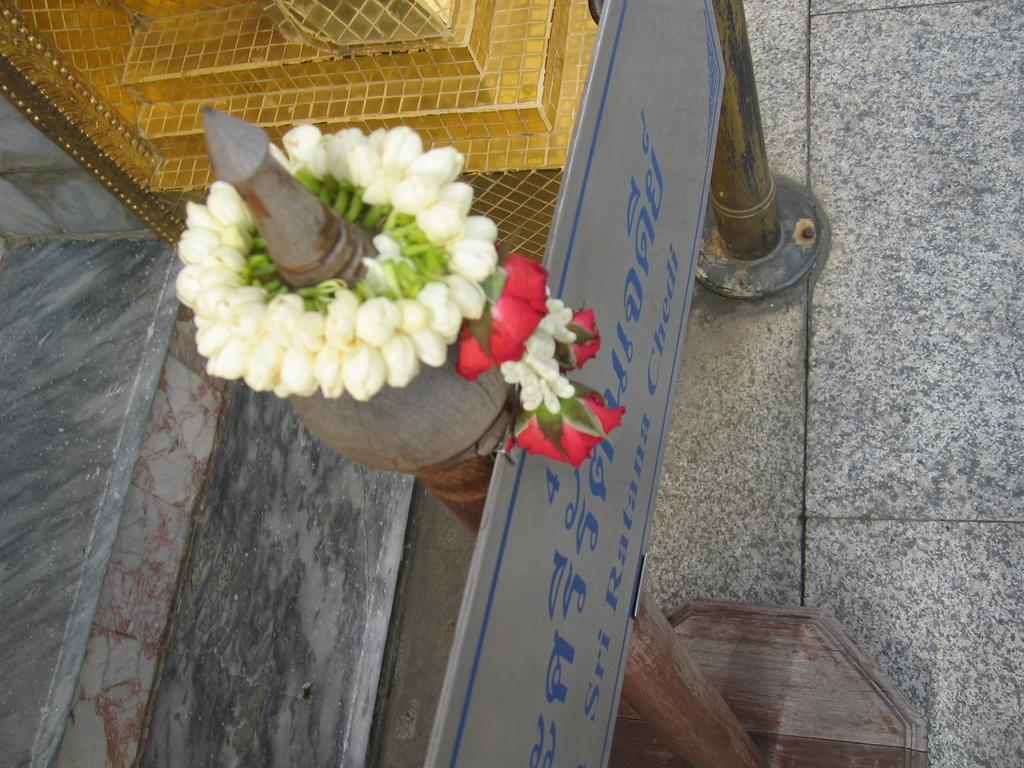What type of plants can be seen in the image? There are flowers in the image. What object is present that might indicate a location or name? There is a name board in the image. What material is used for the rods visible in the image? Metal rods are visible in the image. What news can be heard from the flowers in the image? There is no news present in the image, as it features flowers and other objects. 